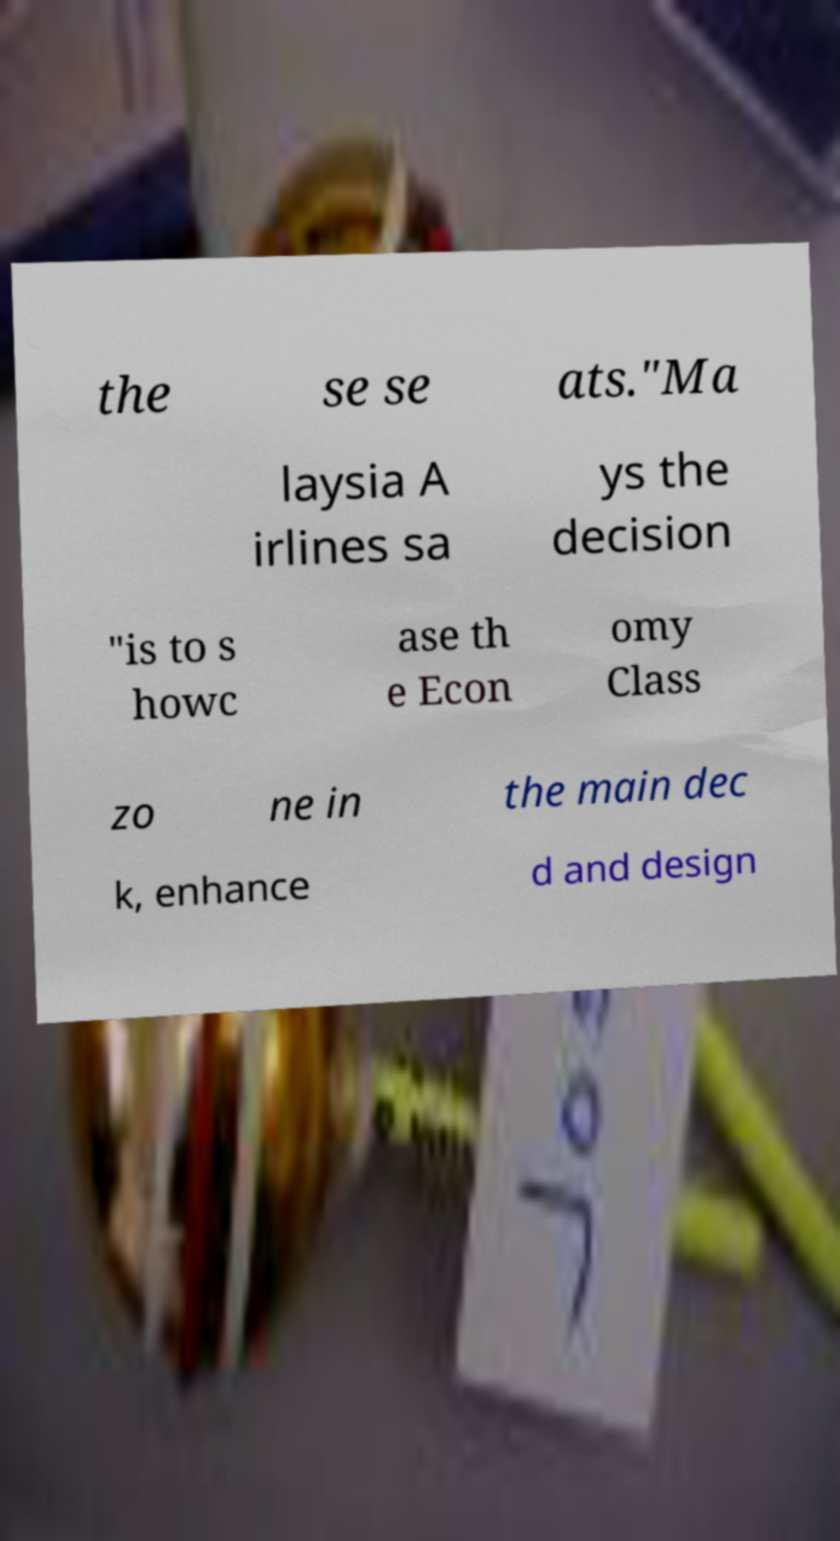Can you accurately transcribe the text from the provided image for me? the se se ats."Ma laysia A irlines sa ys the decision "is to s howc ase th e Econ omy Class zo ne in the main dec k, enhance d and design 